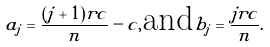<formula> <loc_0><loc_0><loc_500><loc_500>a _ { j } = \frac { ( j + 1 ) r c } { n } - c , \text {and} b _ { j } = \frac { j r c } { n } .</formula> 